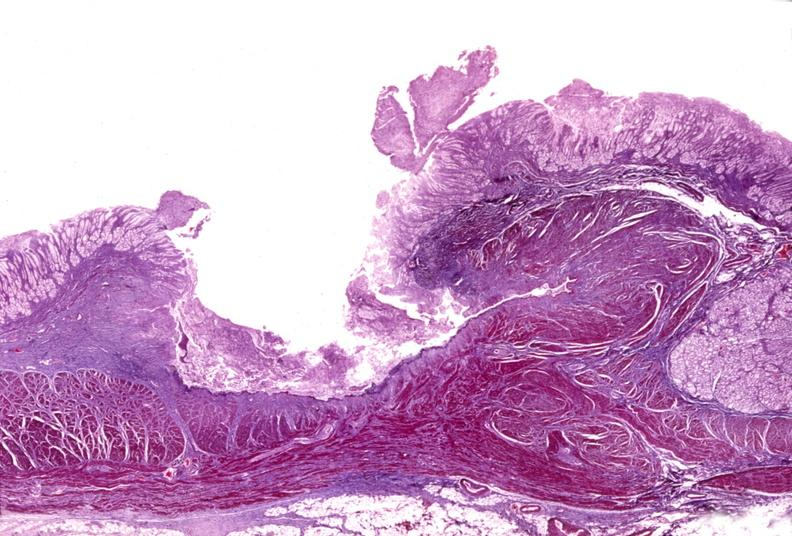s uterus present?
Answer the question using a single word or phrase. No 